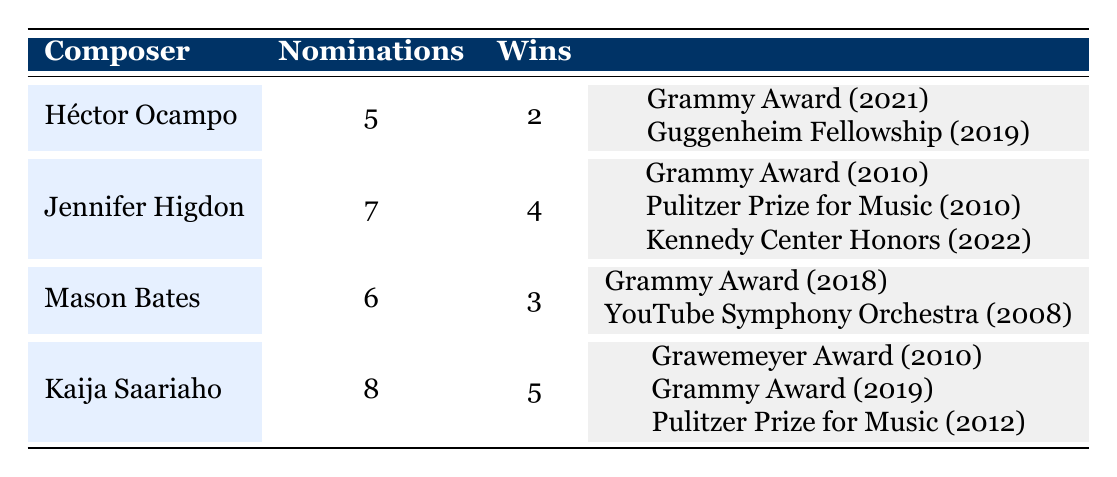What is the total number of nominations across all composers? To find the total nominations, we add the nominations of each composer: 5 (Héctor Ocampo) + 7 (Jennifer Higdon) + 6 (Mason Bates) + 8 (Kaija Saariaho) = 26.
Answer: 26 Which composer has won the most awards? Looking at the wins column, Kaija Saariaho has 5 wins, which is the highest compared to the others (Héctor Ocampo 2, Jennifer Higdon 4, Mason Bates 3).
Answer: Kaija Saariaho How many total wins do Jennifer Higdon and Mason Bates combined have? Adding their wins together gives: 4 (Jennifer Higdon) + 3 (Mason Bates) = 7.
Answer: 7 Is it true that Héctor Ocampo has more nominations than Mason Bates? Comparing their nominations, Héctor Ocampo has 5 and Mason Bates has 6. Thus, Ocampo's nominations are not more than Bates's.
Answer: No What percentage of nominations resulted in wins for Kaija Saariaho? Kaija Saariaho has 8 nominations and 5 wins. To find the percentage: (5 wins / 8 nominations) * 100 = 62.5%.
Answer: 62.5% How many awards did each composer earn in the year 2010? Only two composers have notable awards from 2010: Jennifer Higdon won the Grammy Award and Pulitzer Prize, and Kaija Saariaho won the Grawemeyer Award. Therefore, there are 3 awards in total for that year.
Answer: 3 Is it accurate to say that every composer represented has won at least one Grammy Award? Analyzing the data, each composer has distinct wins and nominations; however, we're specifically looking for Grammy wins: Héctor Ocampo, Jennifer Higdon, Mason Bates, and Kaija Saariaho have each won a Grammy. Thus, it is accurate.
Answer: Yes What is the difference between the nominations of Kaija Saariaho and Jennifer Higdon? Kaija Saariaho has 8 nominations and Jennifer Higdon has 7. The difference is 8 - 7 = 1.
Answer: 1 